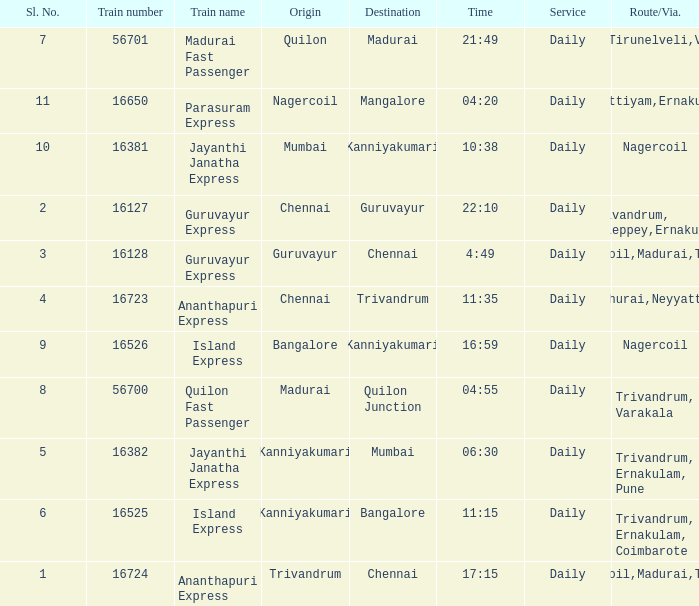What is the origin when the destination is Mumbai? Kanniyakumari. 